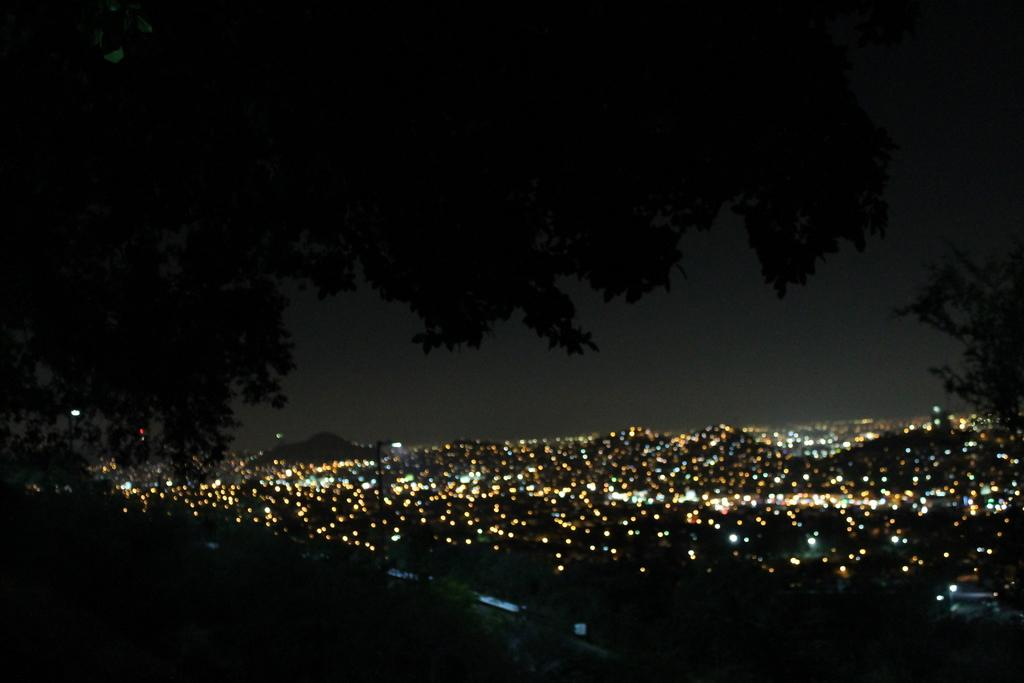What can be seen in the image that provides illumination? There are lights in the image. What type of natural scenery is visible in the background of the image? There are trees in the background of the image. What type of plant is being used to make the eggnog in the image? There is no plant or eggnog present in the image; it only features lights and trees in the background. 